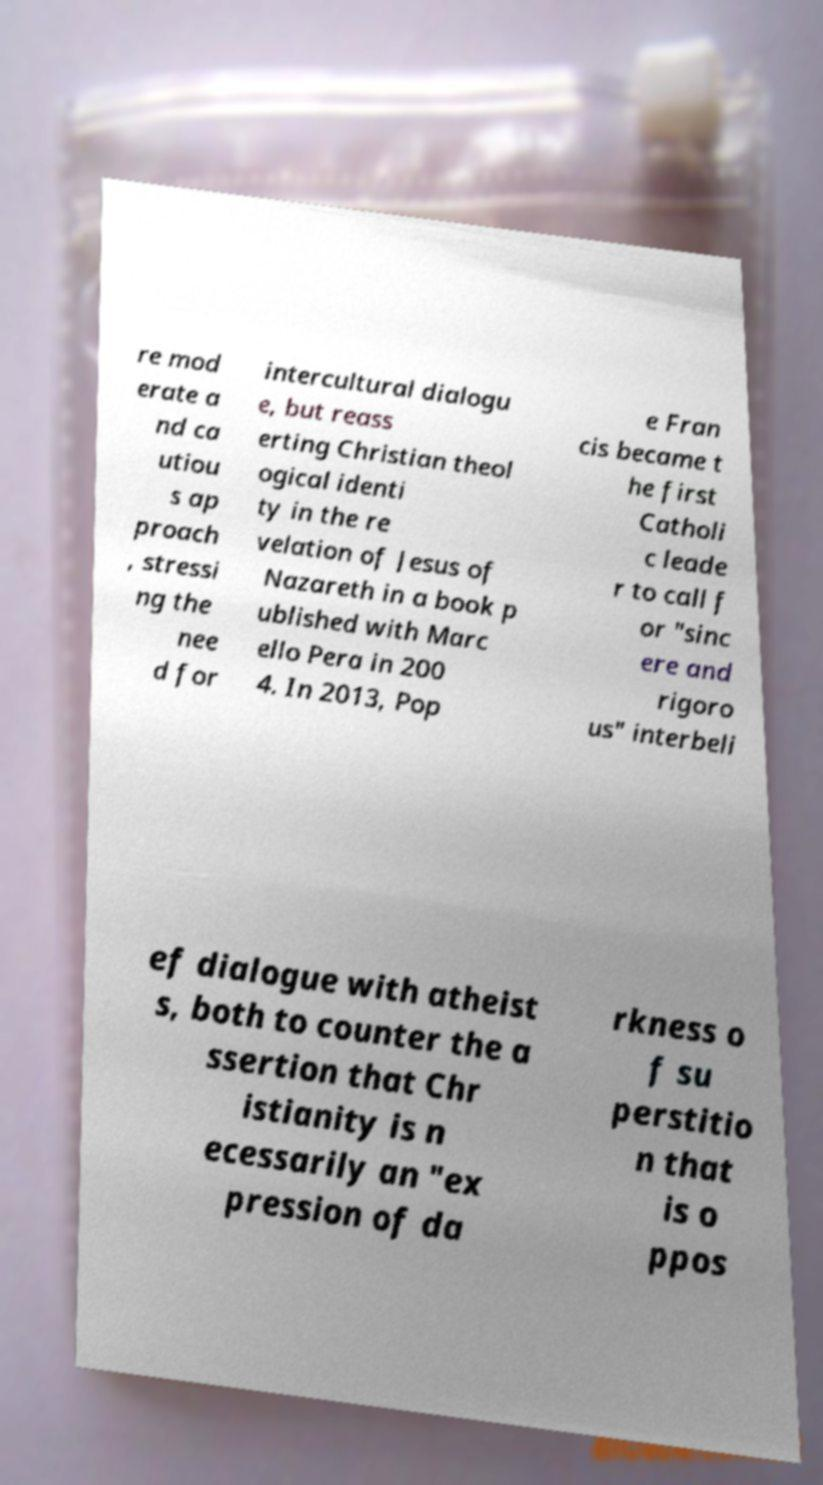Please identify and transcribe the text found in this image. re mod erate a nd ca utiou s ap proach , stressi ng the nee d for intercultural dialogu e, but reass erting Christian theol ogical identi ty in the re velation of Jesus of Nazareth in a book p ublished with Marc ello Pera in 200 4. In 2013, Pop e Fran cis became t he first Catholi c leade r to call f or "sinc ere and rigoro us" interbeli ef dialogue with atheist s, both to counter the a ssertion that Chr istianity is n ecessarily an "ex pression of da rkness o f su perstitio n that is o ppos 